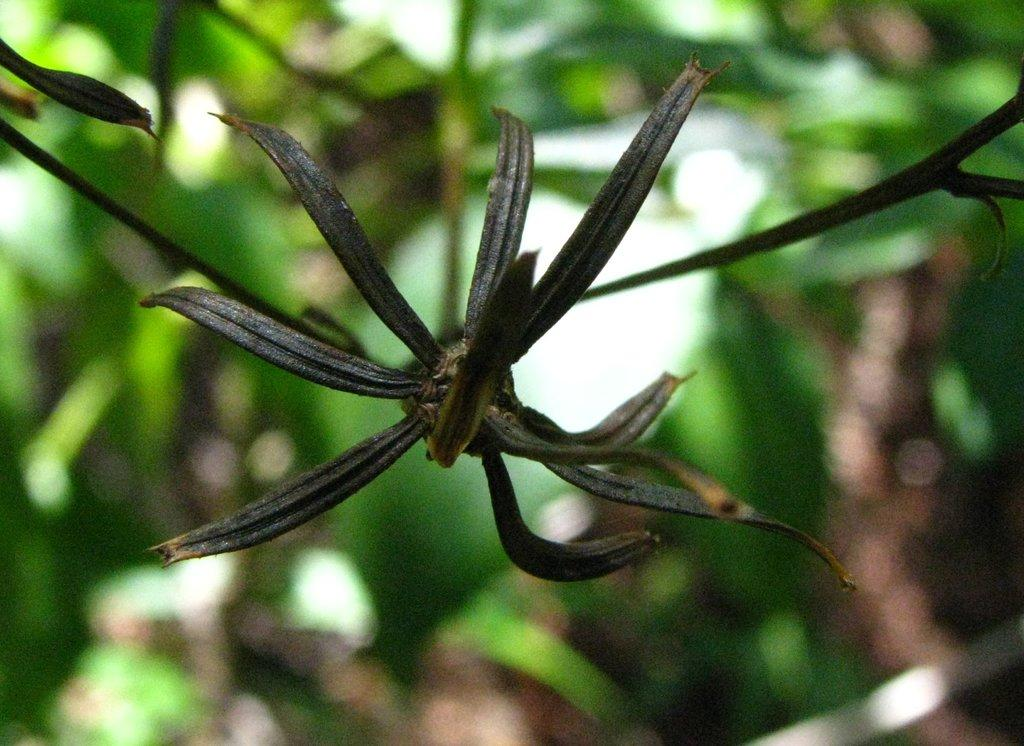What type of living organism can be seen in the image? There is a plant in the image. What can be seen in the background of the image? There appears to be a tree in the background of the image. What type of tool is being used to lift the plant in the image? There is no tool or lifting action present in the image; it simply shows a plant and a tree in the background. 